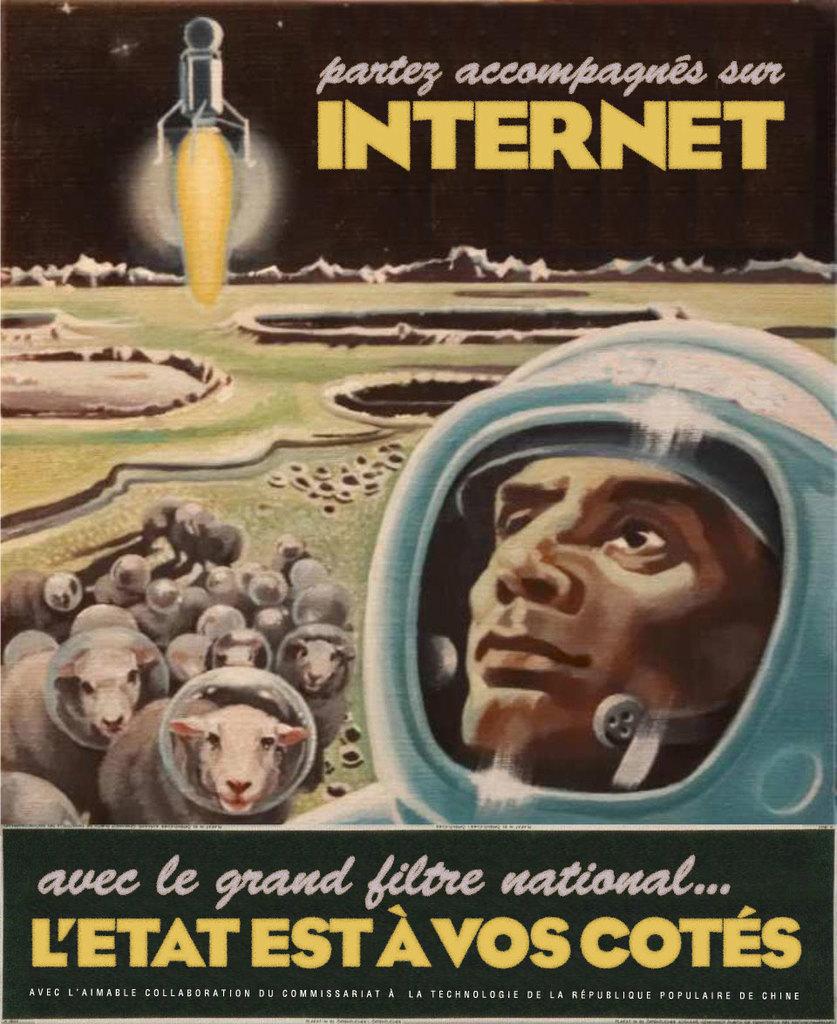What is the text on the top of the poster?
Ensure brevity in your answer.  Partez accompagnes sur. 